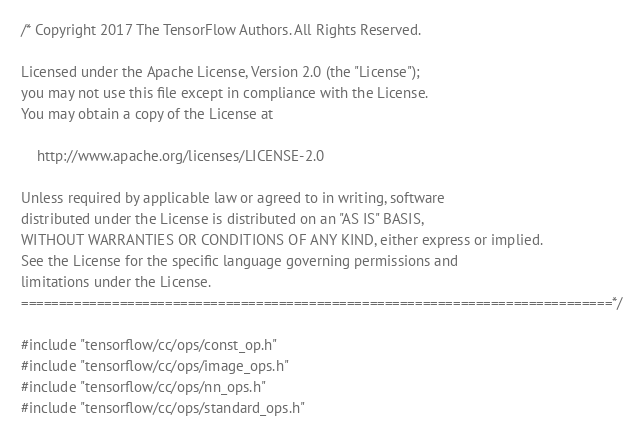Convert code to text. <code><loc_0><loc_0><loc_500><loc_500><_C++_>/* Copyright 2017 The TensorFlow Authors. All Rights Reserved.

Licensed under the Apache License, Version 2.0 (the "License");
you may not use this file except in compliance with the License.
You may obtain a copy of the License at

    http://www.apache.org/licenses/LICENSE-2.0

Unless required by applicable law or agreed to in writing, software
distributed under the License is distributed on an "AS IS" BASIS,
WITHOUT WARRANTIES OR CONDITIONS OF ANY KIND, either express or implied.
See the License for the specific language governing permissions and
limitations under the License.
==============================================================================*/

#include "tensorflow/cc/ops/const_op.h"
#include "tensorflow/cc/ops/image_ops.h"
#include "tensorflow/cc/ops/nn_ops.h"
#include "tensorflow/cc/ops/standard_ops.h"</code> 